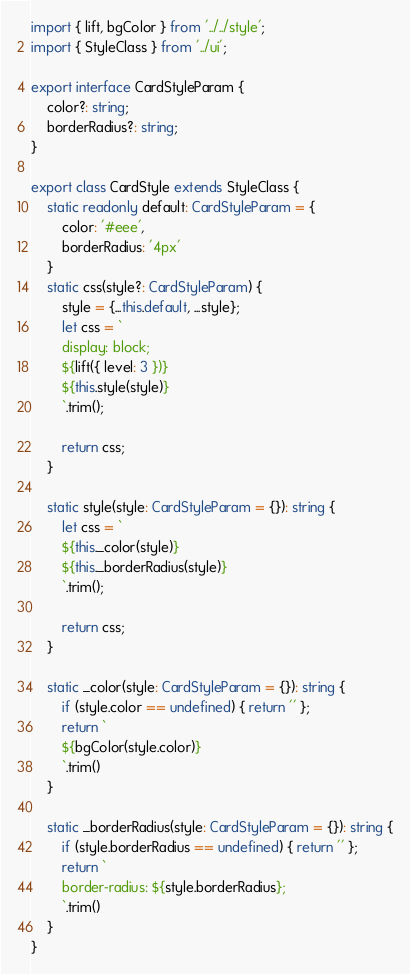Convert code to text. <code><loc_0><loc_0><loc_500><loc_500><_TypeScript_>import { lift, bgColor } from '../../style';
import { StyleClass } from '../ui';

export interface CardStyleParam {
    color?: string;
    borderRadius?: string;
}

export class CardStyle extends StyleClass {
    static readonly default: CardStyleParam = {
        color: '#eee',
        borderRadius: '4px'
    }
    static css(style?: CardStyleParam) {
        style = {...this.default, ...style};
        let css = `
        display: block;
        ${lift({ level: 3 })}
        ${this.style(style)}
        `.trim();

        return css;
    }

    static style(style: CardStyleParam = {}): string {
        let css = `
        ${this._color(style)}
        ${this._borderRadius(style)}
        `.trim();

        return css;
    }

    static _color(style: CardStyleParam = {}): string {
        if (style.color == undefined) { return '' };
        return `
        ${bgColor(style.color)}
        `.trim()
    }

    static _borderRadius(style: CardStyleParam = {}): string {
        if (style.borderRadius == undefined) { return '' };
        return `
        border-radius: ${style.borderRadius};
        `.trim()
    }
}</code> 